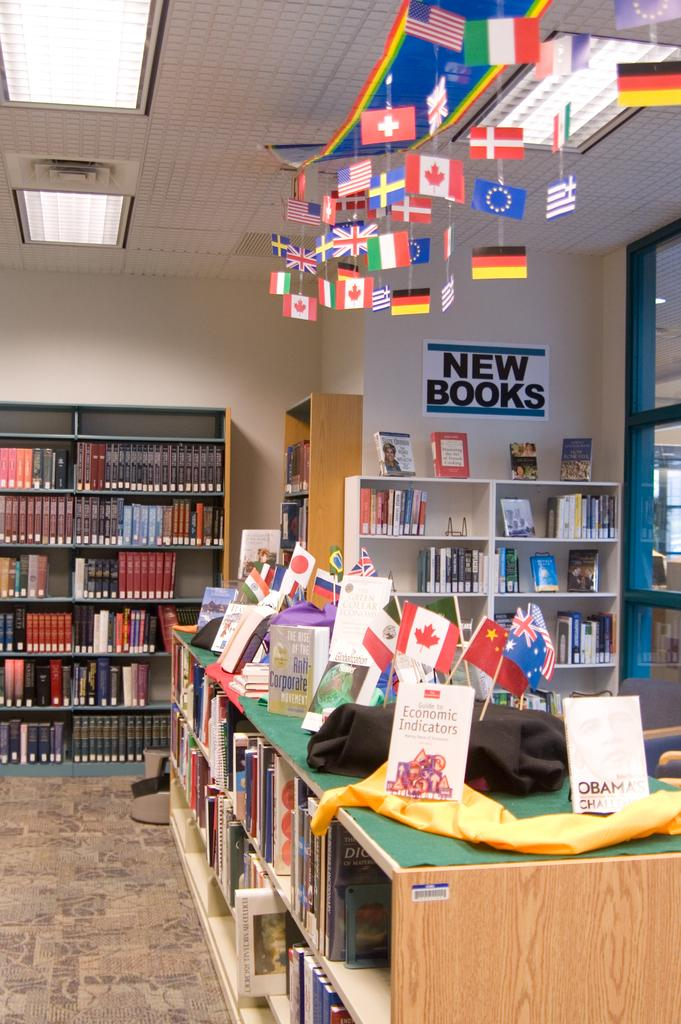Provide a one-sentence caption for the provided image. A shelf of books against the wall in a library under a sign that says New Books. 